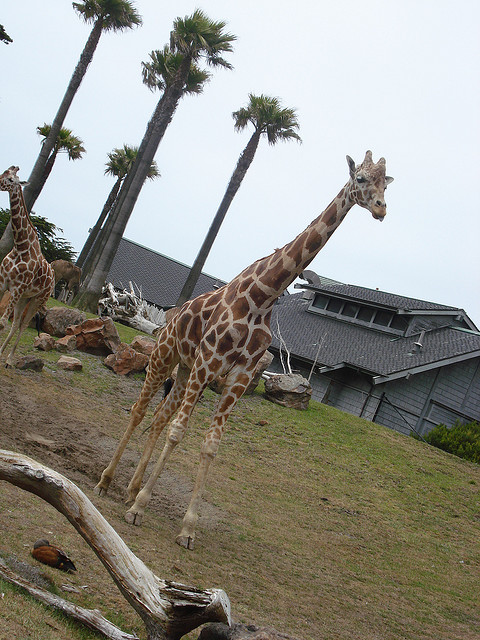<image>Where is the shrubbery? It is ambiguous where the shrubbery is located. It could be by the building or behind the pines. Where is the shrubbery? It is unknown where the shrubbery is located. 